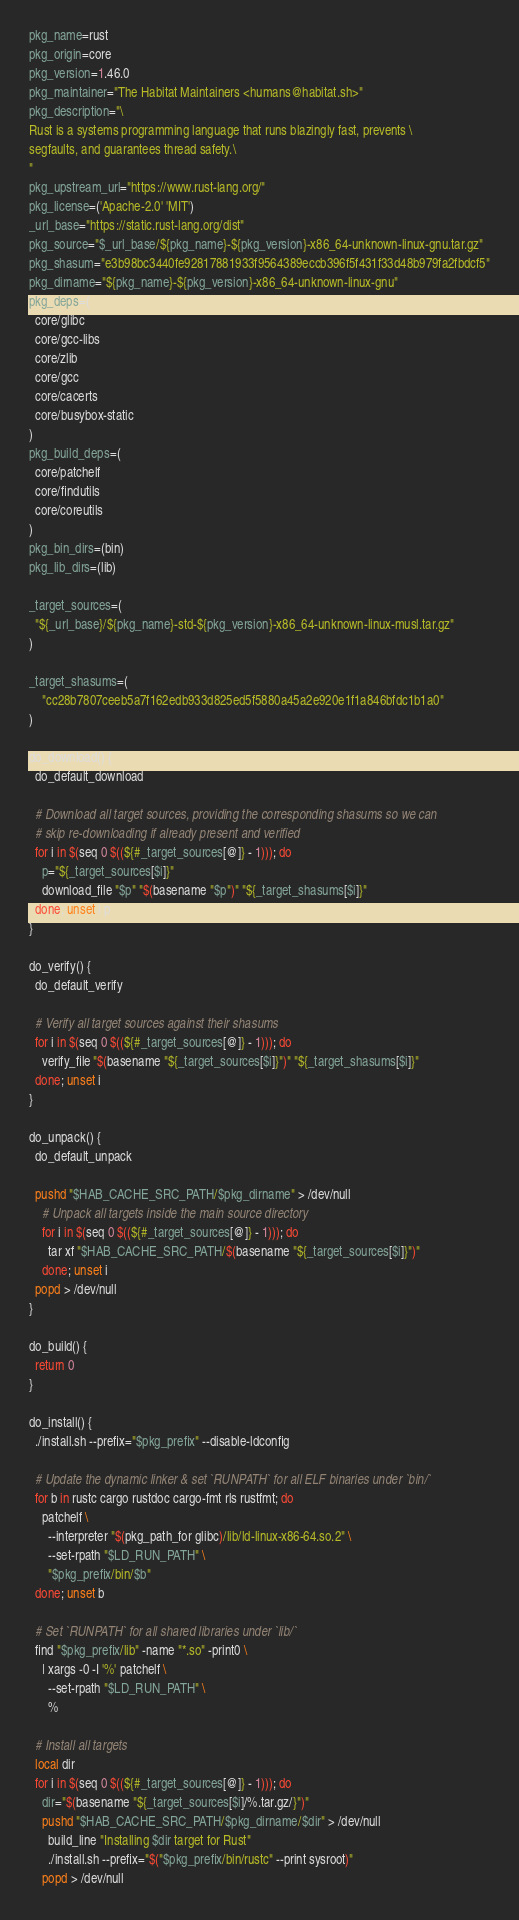<code> <loc_0><loc_0><loc_500><loc_500><_Bash_>pkg_name=rust
pkg_origin=core
pkg_version=1.46.0
pkg_maintainer="The Habitat Maintainers <humans@habitat.sh>"
pkg_description="\
Rust is a systems programming language that runs blazingly fast, prevents \
segfaults, and guarantees thread safety.\
"
pkg_upstream_url="https://www.rust-lang.org/"
pkg_license=('Apache-2.0' 'MIT')
_url_base="https://static.rust-lang.org/dist"
pkg_source="$_url_base/${pkg_name}-${pkg_version}-x86_64-unknown-linux-gnu.tar.gz"
pkg_shasum="e3b98bc3440fe92817881933f9564389eccb396f5f431f33d48b979fa2fbdcf5"
pkg_dirname="${pkg_name}-${pkg_version}-x86_64-unknown-linux-gnu"
pkg_deps=(
  core/glibc
  core/gcc-libs
  core/zlib
  core/gcc
  core/cacerts
  core/busybox-static
)
pkg_build_deps=(
  core/patchelf
  core/findutils
  core/coreutils
)
pkg_bin_dirs=(bin)
pkg_lib_dirs=(lib)

_target_sources=(
  "${_url_base}/${pkg_name}-std-${pkg_version}-x86_64-unknown-linux-musl.tar.gz"
)

_target_shasums=(
    "cc28b7807ceeb5a7f162edb933d825ed5f5880a45a2e920e1f1a846bfdc1b1a0"
)

do_download() {
  do_default_download

  # Download all target sources, providing the corresponding shasums so we can
  # skip re-downloading if already present and verified
  for i in $(seq 0 $((${#_target_sources[@]} - 1))); do
    p="${_target_sources[$i]}"
    download_file "$p" "$(basename "$p")" "${_target_shasums[$i]}"
  done; unset i p
}

do_verify() {
  do_default_verify

  # Verify all target sources against their shasums
  for i in $(seq 0 $((${#_target_sources[@]} - 1))); do
    verify_file "$(basename "${_target_sources[$i]}")" "${_target_shasums[$i]}"
  done; unset i
}

do_unpack() {
  do_default_unpack

  pushd "$HAB_CACHE_SRC_PATH/$pkg_dirname" > /dev/null
    # Unpack all targets inside the main source directory
    for i in $(seq 0 $((${#_target_sources[@]} - 1))); do
      tar xf "$HAB_CACHE_SRC_PATH/$(basename "${_target_sources[$i]}")"
    done; unset i
  popd > /dev/null
}

do_build() {
  return 0
}

do_install() {
  ./install.sh --prefix="$pkg_prefix" --disable-ldconfig

  # Update the dynamic linker & set `RUNPATH` for all ELF binaries under `bin/`
  for b in rustc cargo rustdoc cargo-fmt rls rustfmt; do
    patchelf \
      --interpreter "$(pkg_path_for glibc)/lib/ld-linux-x86-64.so.2" \
      --set-rpath "$LD_RUN_PATH" \
      "$pkg_prefix/bin/$b"
  done; unset b

  # Set `RUNPATH` for all shared libraries under `lib/`
  find "$pkg_prefix/lib" -name "*.so" -print0 \
    | xargs -0 -I '%' patchelf \
      --set-rpath "$LD_RUN_PATH" \
      %

  # Install all targets
  local dir
  for i in $(seq 0 $((${#_target_sources[@]} - 1))); do
    dir="$(basename "${_target_sources[$i]/%.tar.gz/}")"
    pushd "$HAB_CACHE_SRC_PATH/$pkg_dirname/$dir" > /dev/null
      build_line "Installing $dir target for Rust"
      ./install.sh --prefix="$("$pkg_prefix/bin/rustc" --print sysroot)"
    popd > /dev/null</code> 